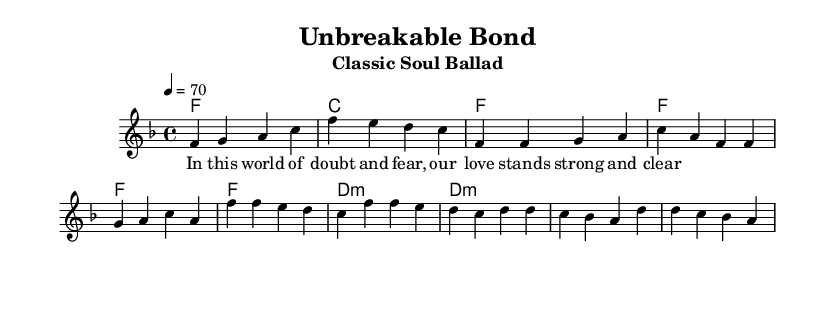What is the key signature of this music? The key signature is indicated by the note symbols at the beginning of the staff; in this case, it shows one flat, which denotes the key of F major.
Answer: F major What is the time signature of this music? The time signature appears at the beginning of the score, showing a 4 over 4, indicating that there are four beats in each measure and a quarter note gets one beat.
Answer: 4/4 What is the tempo marking of this piece? The tempo marking, indicated after the time signature, specifies the pace of the music, in this case, it states a speed of 70 beats per minute.
Answer: 70 How many measures are in the chorus section? The chorus section starts from the marked section after the verse, and it consists of two measures, each with four beats as described in the melody.
Answer: 2 What type of chord is used in the bridge? The bridge section has a chord that is labeled with an 'm' indicating it is a minor chord, specifically the D minor chord is used throughout this section.
Answer: D minor What lyrical theme does the song explore? The lyrics, which reflect trust and loyalty in relationships, convey a message about love enduring despite trials, as noted in the provided verse text.
Answer: Trust and loyalty How does the structure of this piece reflect classic soul ballads? The structure includes distinct sections—intro, verse, chorus, and bridge—following a traditional format typical of classic soul ballads, emphasizing emotional expression and narrative.
Answer: Traditional format 